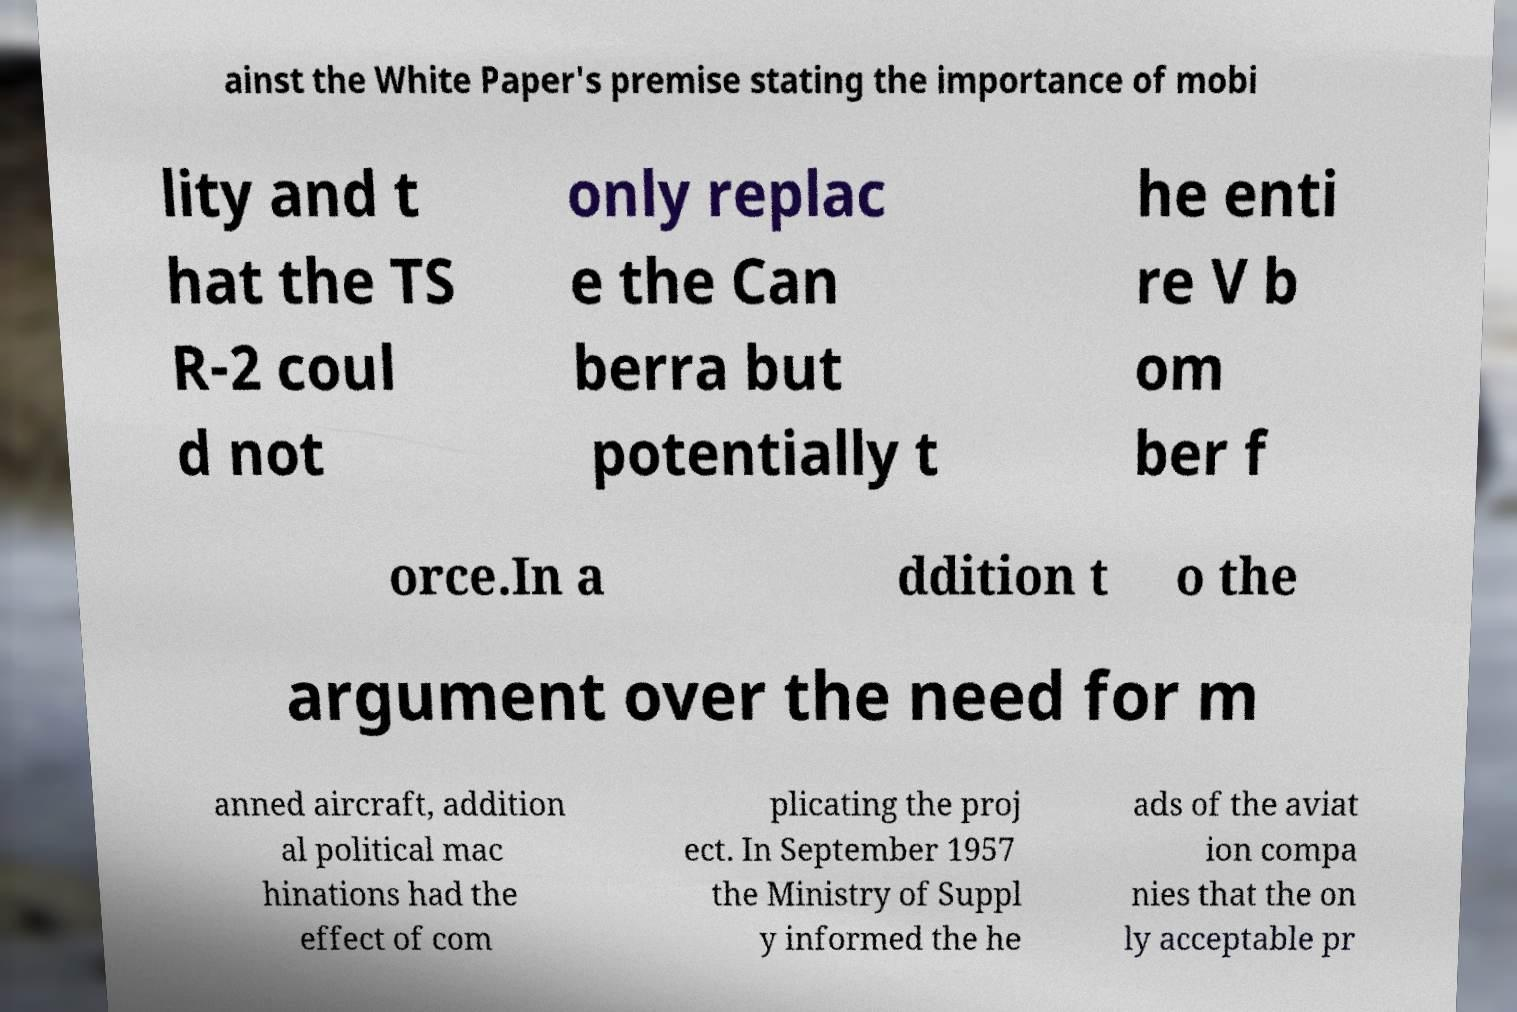Can you read and provide the text displayed in the image?This photo seems to have some interesting text. Can you extract and type it out for me? ainst the White Paper's premise stating the importance of mobi lity and t hat the TS R-2 coul d not only replac e the Can berra but potentially t he enti re V b om ber f orce.In a ddition t o the argument over the need for m anned aircraft, addition al political mac hinations had the effect of com plicating the proj ect. In September 1957 the Ministry of Suppl y informed the he ads of the aviat ion compa nies that the on ly acceptable pr 